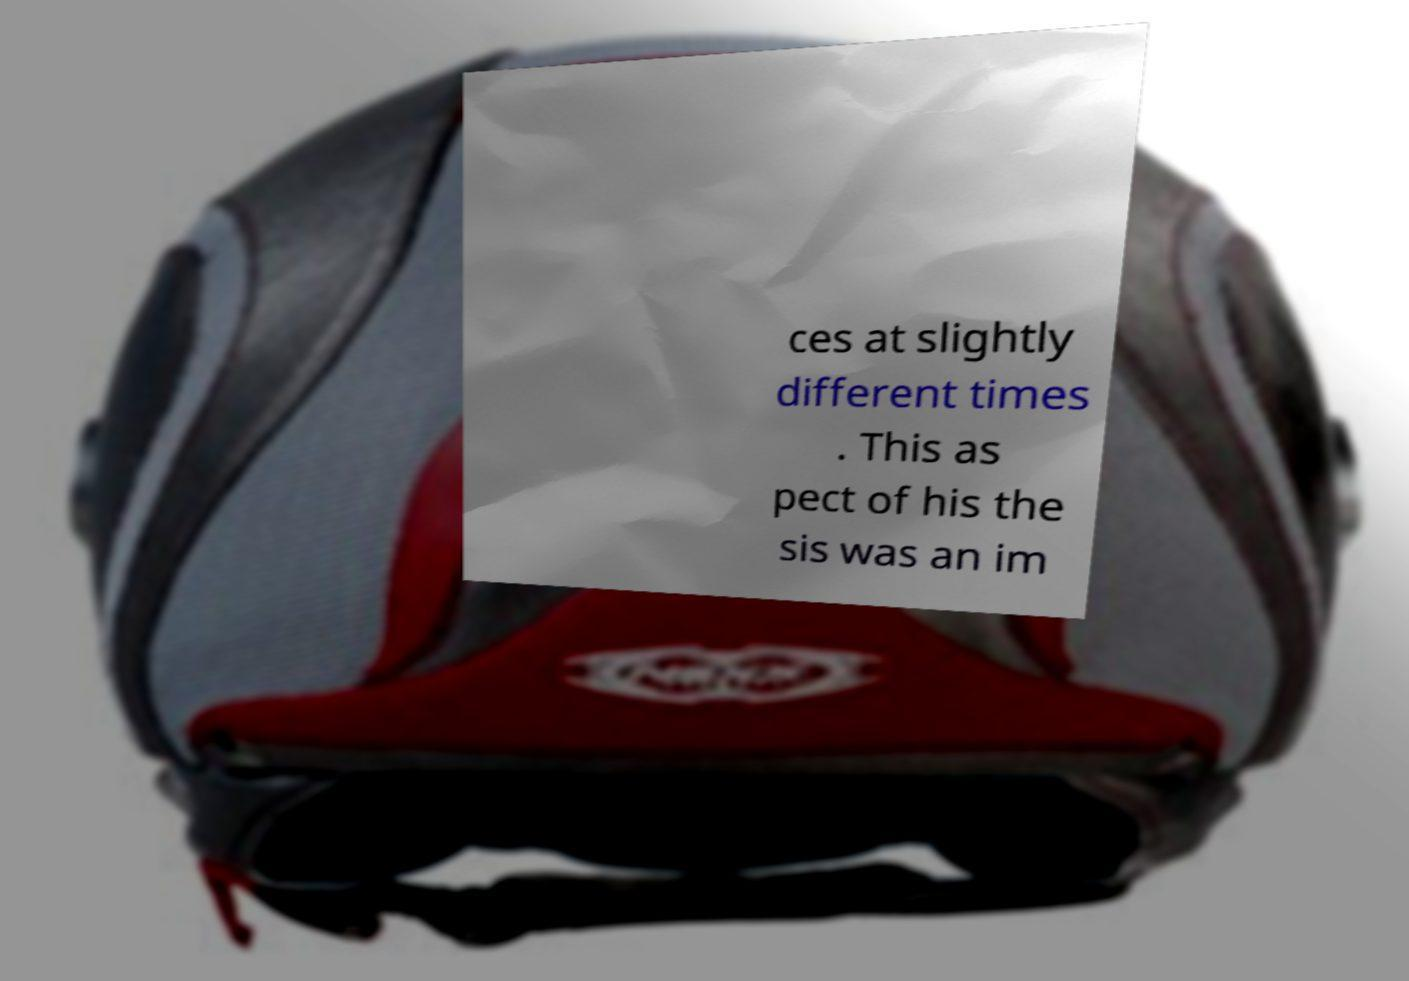Could you assist in decoding the text presented in this image and type it out clearly? ces at slightly different times . This as pect of his the sis was an im 